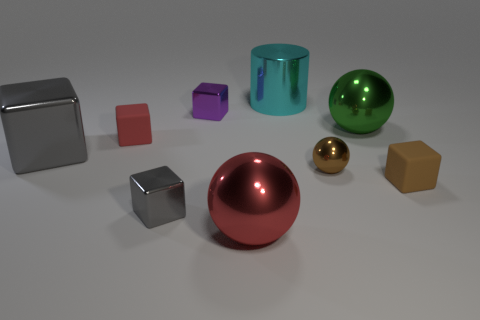Subtract all brown blocks. How many blocks are left? 4 Subtract all small gray blocks. How many blocks are left? 4 Subtract 1 cubes. How many cubes are left? 4 Add 1 cyan cubes. How many objects exist? 10 Subtract all cyan cubes. Subtract all cyan cylinders. How many cubes are left? 5 Add 2 shiny objects. How many shiny objects are left? 9 Add 5 small cyan shiny spheres. How many small cyan shiny spheres exist? 5 Subtract 0 cyan cubes. How many objects are left? 9 Subtract all cubes. How many objects are left? 4 Subtract all red rubber things. Subtract all big red things. How many objects are left? 7 